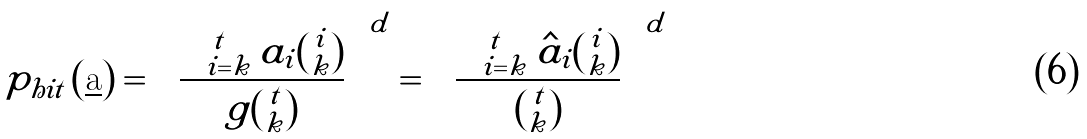<formula> <loc_0><loc_0><loc_500><loc_500>p _ { h i t } \left ( \underline { \text {a} } \right ) = \left ( \frac { \sum _ { i = k } ^ { t } a _ { i } \binom { i } { k } } { g \binom { t } { k } } \right ) ^ { d } = \left ( \frac { \sum _ { i = k } ^ { t } \hat { a } _ { i } \binom { i } { k } } { \binom { t } { k } } \right ) ^ { d }</formula> 